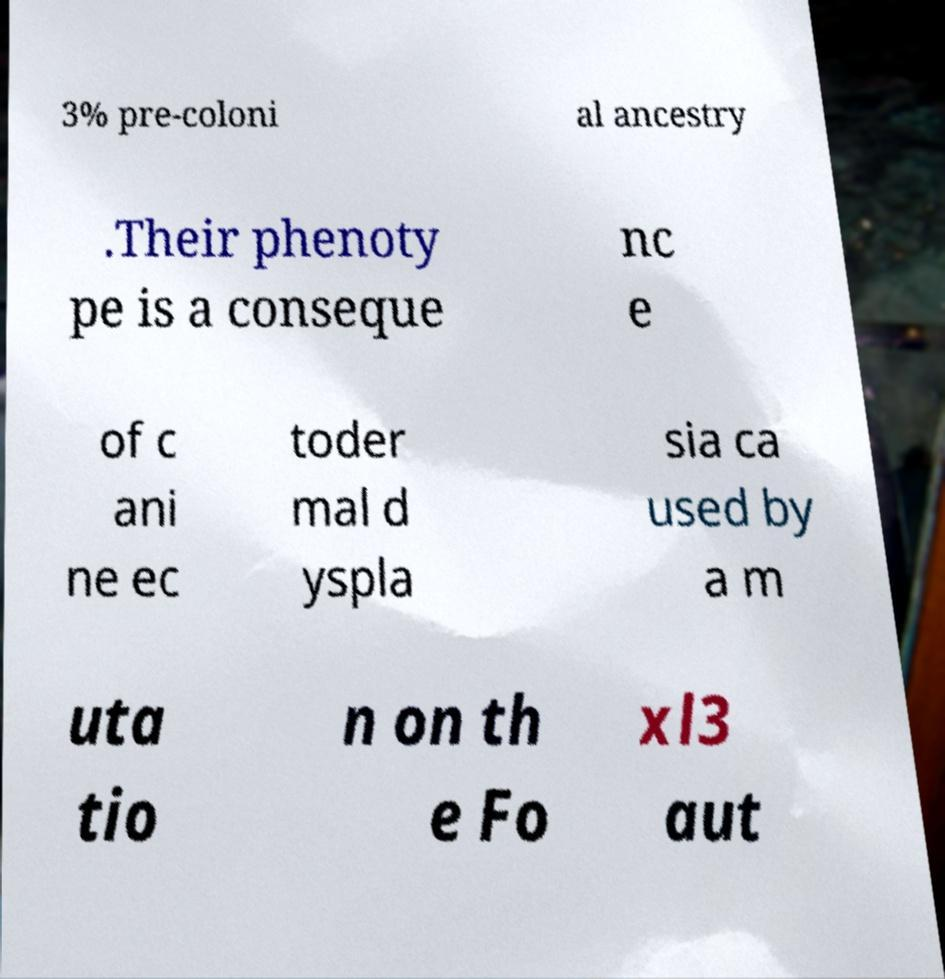I need the written content from this picture converted into text. Can you do that? 3% pre-coloni al ancestry .Their phenoty pe is a conseque nc e of c ani ne ec toder mal d yspla sia ca used by a m uta tio n on th e Fo xl3 aut 